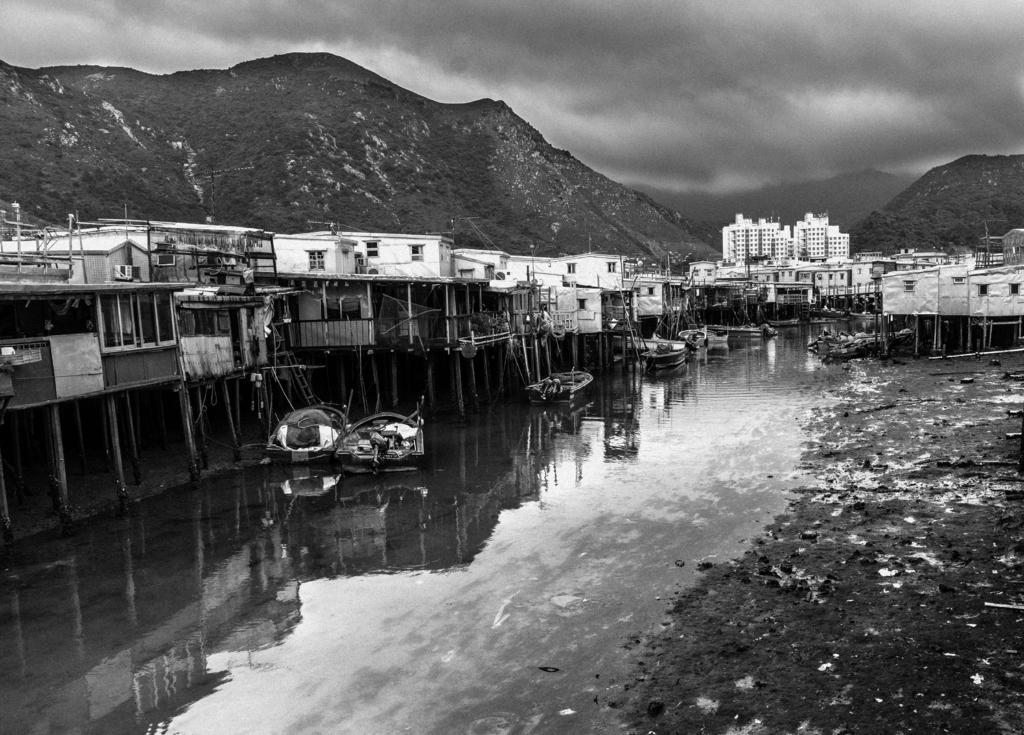Describe this image in one or two sentences. In this picture I can see the water in front, on which there are few boats and I see number of buildings. In the background I can see the mountains and I see the cloudy sky. 